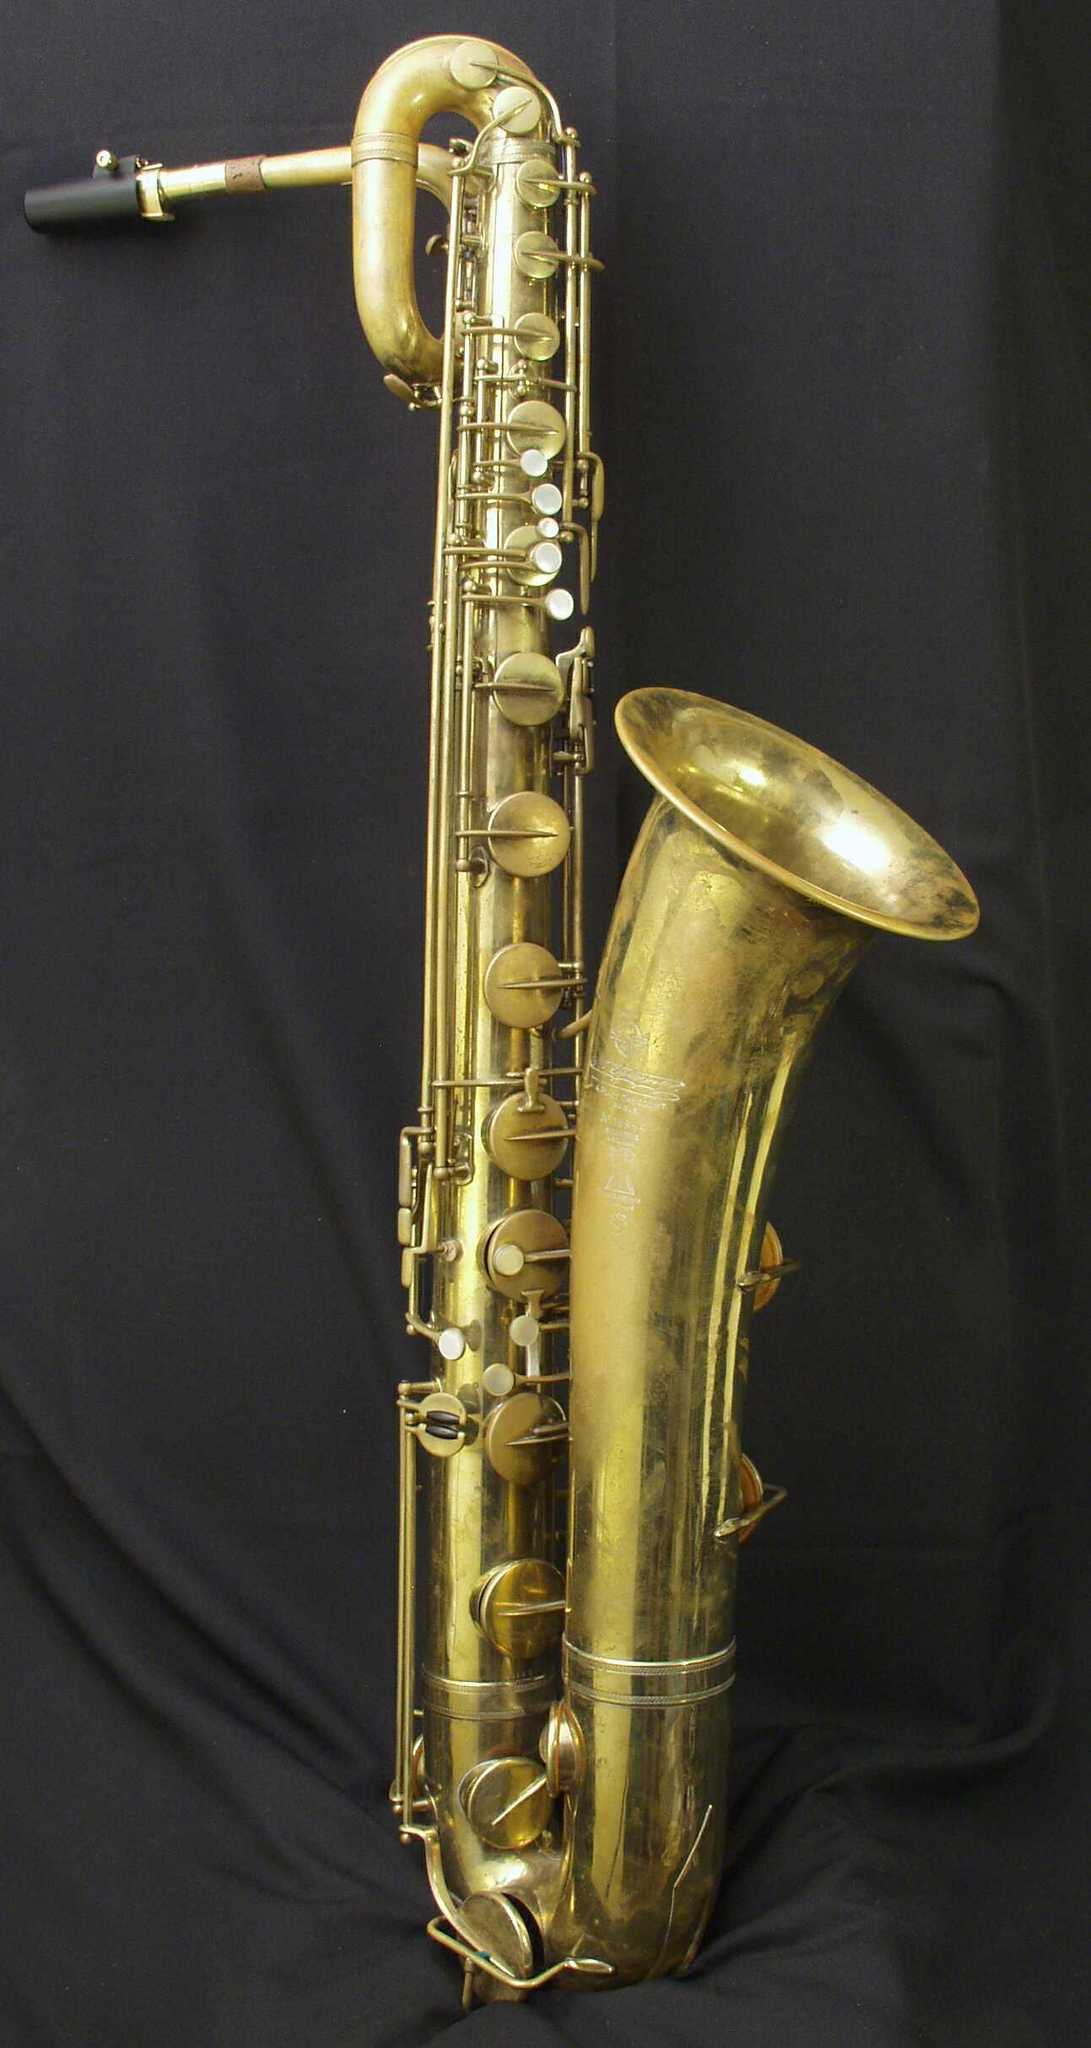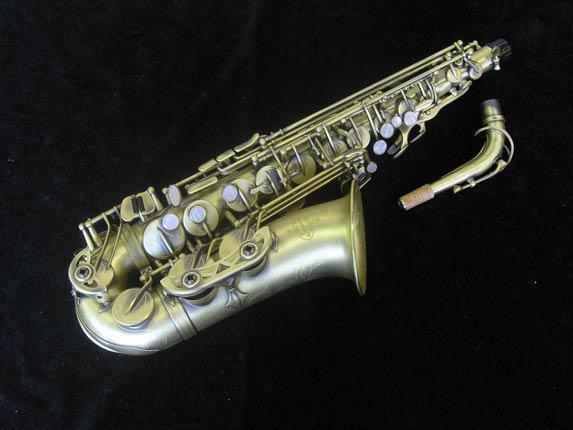The first image is the image on the left, the second image is the image on the right. Given the left and right images, does the statement "The image on the right has a solid black background." hold true? Answer yes or no. Yes. The first image is the image on the left, the second image is the image on the right. Examine the images to the left and right. Is the description "All of the instruments are facing the same direction." accurate? Answer yes or no. Yes. 